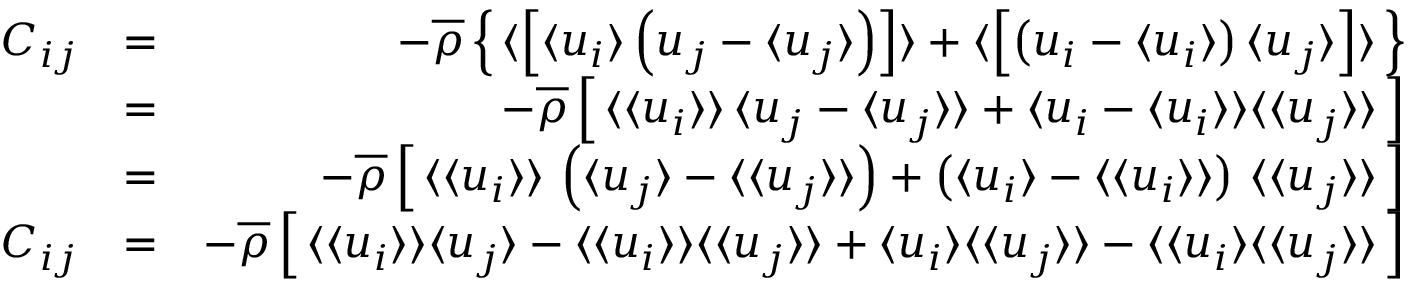<formula> <loc_0><loc_0><loc_500><loc_500>\begin{array} { r l r } { C _ { i j } } & { = } & { - \overline { \rho } \left \{ \, \langle \left [ { \langle u _ { i } \rangle \left ( u _ { j } - \langle u _ { j } \rangle \right ) } \right ] \rangle + \langle \left [ { \left ( u _ { i } - \langle u _ { i } \rangle \right ) \langle u _ { j } \rangle } \right ] \rangle \, \right \} } \\ & { = } & { - \overline { \rho } \left [ \, \langle \langle u _ { i } \rangle \rangle \, \langle u _ { j } - \langle u _ { j } \rangle \rangle + \langle u _ { i } - \langle u _ { i } \rangle \rangle \langle \langle u _ { j } \rangle \rangle \, \right ] } \\ & { = } & { - \overline { \rho } \left [ \, \langle \langle u _ { i } \rangle \rangle \, \left ( \langle u _ { j } \rangle - \langle \langle u _ { j } \rangle \rangle \right ) + \left ( \langle u _ { i } \rangle - \langle \langle u _ { i } \rangle \rangle \right ) \, \langle \langle u _ { j } \rangle \rangle \, \right ] } \\ { C _ { i j } } & { = } & { - \overline { \rho } \left [ \, \langle \langle u _ { i } \rangle \rangle \langle u _ { j } \rangle - \langle \langle u _ { i } \rangle \rangle \langle \langle u _ { j } \rangle \rangle + \langle u _ { i } \rangle \langle \langle u _ { j } \rangle \rangle - \langle \langle u _ { i } \rangle \langle \langle u _ { j } \rangle \rangle \, \right ] } \end{array}</formula> 